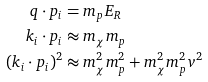<formula> <loc_0><loc_0><loc_500><loc_500>q \cdot p _ { i } & = m _ { p } E _ { R } \\ k _ { i } \cdot p _ { i } & \approx m _ { \chi } m _ { p } \\ ( k _ { i } \cdot p _ { i } ) ^ { 2 } & \approx m _ { \chi } ^ { 2 } m _ { p } ^ { 2 } + m _ { \chi } ^ { 2 } m _ { p } ^ { 2 } v ^ { 2 }</formula> 